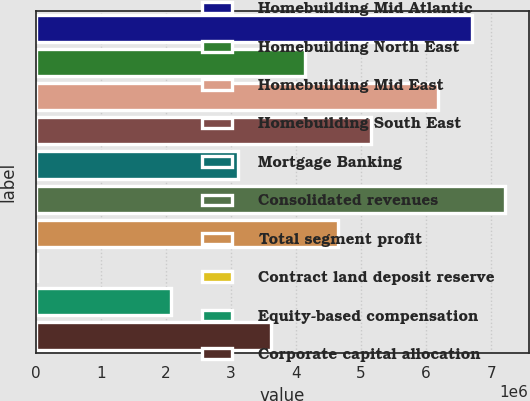Convert chart. <chart><loc_0><loc_0><loc_500><loc_500><bar_chart><fcel>Homebuilding Mid Atlantic<fcel>Homebuilding North East<fcel>Homebuilding Mid East<fcel>Homebuilding South East<fcel>Mortgage Banking<fcel>Consolidated revenues<fcel>Total segment profit<fcel>Contract land deposit reserve<fcel>Equity-based compensation<fcel>Corporate capital allocation<nl><fcel>6.70257e+06<fcel>4.12997e+06<fcel>6.18805e+06<fcel>5.15901e+06<fcel>3.10093e+06<fcel>7.21709e+06<fcel>4.64449e+06<fcel>13805<fcel>2.07189e+06<fcel>3.61545e+06<nl></chart> 